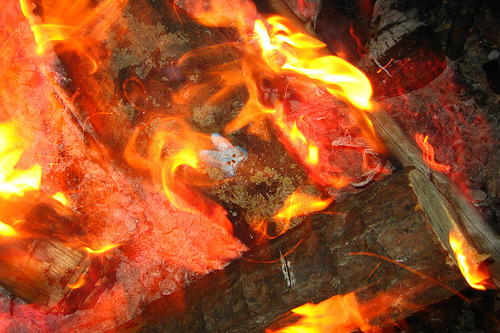<image>
Is the rabbit head in the fire? Yes. The rabbit head is contained within or inside the fire, showing a containment relationship. 